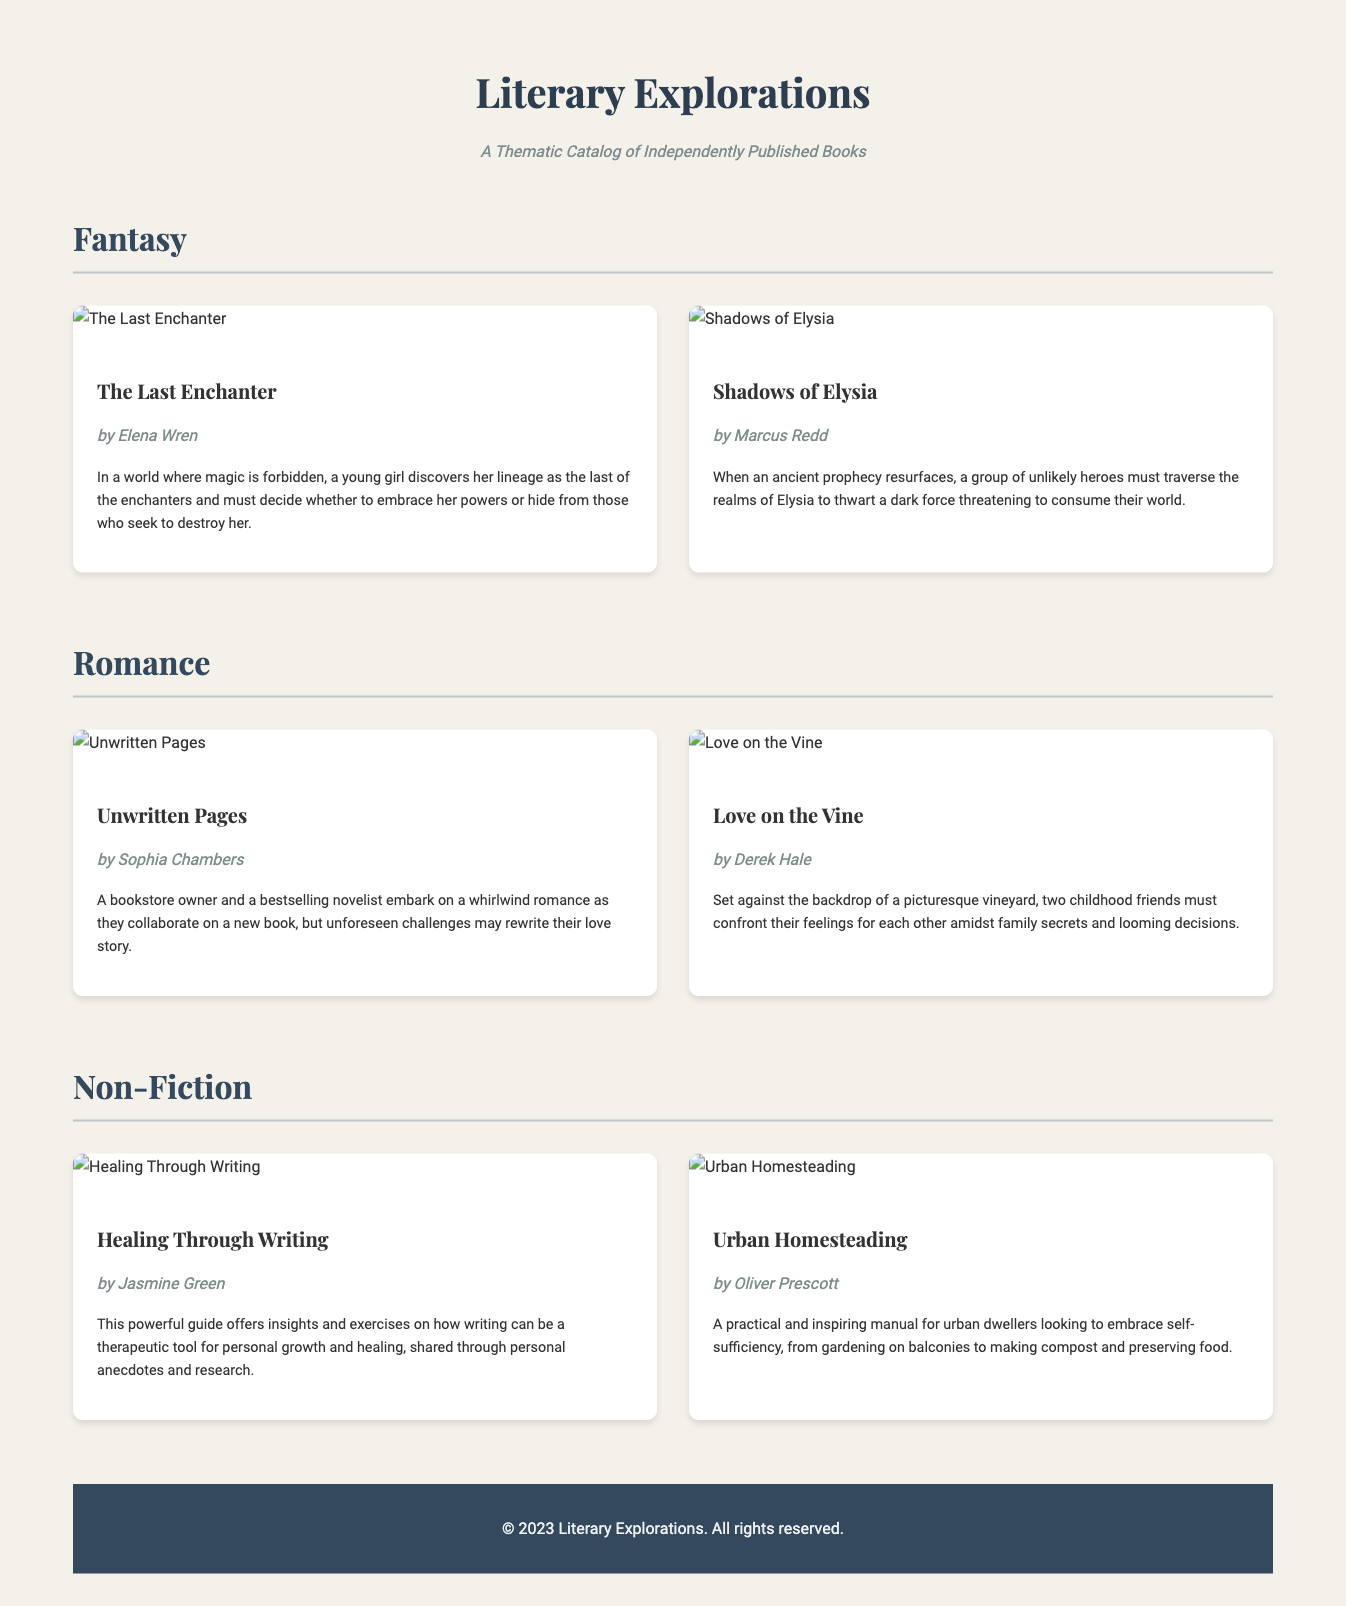What is the title of the fantasy book by Elena Wren? The document provides the title of the book under the fantasy genre by Elena Wren as "The Last Enchanter."
Answer: The Last Enchanter Who is the author of "Unwritten Pages"? The document states that the author of "Unwritten Pages" is Sophia Chambers.
Answer: Sophia Chambers How many books are listed under the Romance genre? The document lists a total of two books under the Romance genre.
Answer: 2 What is the main theme of "Healing Through Writing"? The summary in the document indicates that the main theme is about using writing as a therapeutic tool for personal growth and healing.
Answer: Therapeutic tool Which book features a picturesque vineyard setting? The document mentions that "Love on the Vine" is set against the backdrop of a picturesque vineyard.
Answer: Love on the Vine What genre does "Urban Homesteading" belong to? The document categorizes "Urban Homesteading" under the Non-Fiction genre.
Answer: Non-Fiction What type of manual is "Urban Homesteading"? The document describes "Urban Homesteading" as a practical and inspiring manual for urban dwellers.
Answer: Practical manual Who are the two authors featured in the Non-Fiction section? The document provides the names of the authors in the Non-Fiction section as Jasmine Green and Oliver Prescott.
Answer: Jasmine Green, Oliver Prescott What is the subtitle of the catalog? The document displays the subtitle as "A Thematic Catalog of Independently Published Books."
Answer: A Thematic Catalog of Independently Published Books 